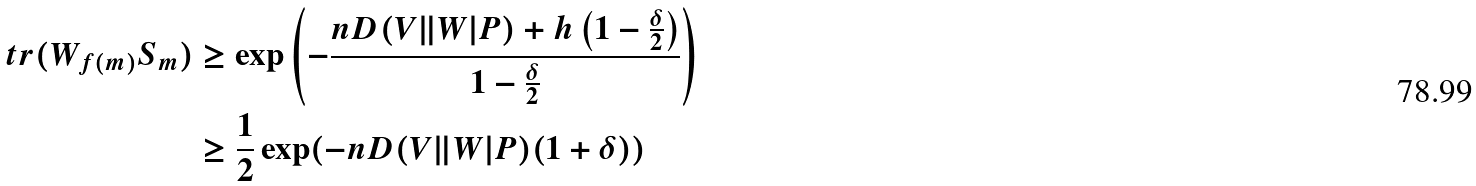Convert formula to latex. <formula><loc_0><loc_0><loc_500><loc_500>\ t r ( W _ { f ( m ) } S _ { m } ) & \geq \exp \left ( - \frac { n D ( V \| W | P ) + h \left ( 1 - \frac { \delta } { 2 } \right ) } { 1 - \frac { \delta } { 2 } } \right ) \\ & \geq \frac { 1 } { 2 } \exp ( - n D ( V \| W | P ) ( 1 + \delta ) )</formula> 